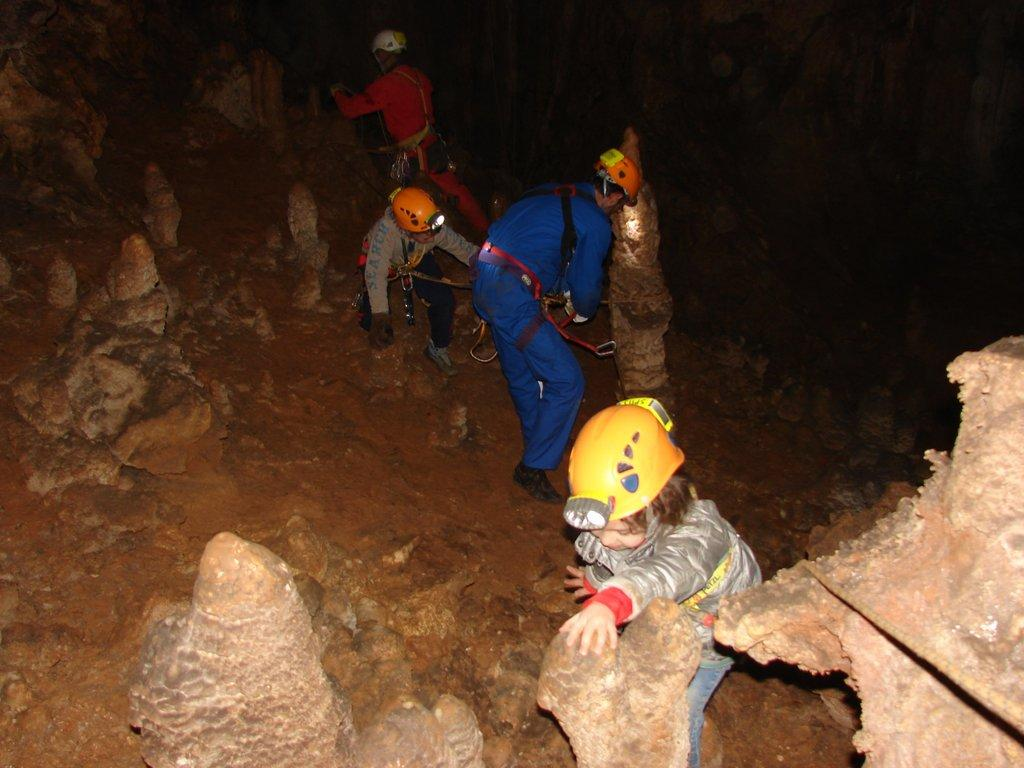How many people are in the image? There are four people in the image. What are the people wearing on their heads? The people are wearing helmets. What is unique about the helmets they are wearing? The helmets have lights attached to them. What can be seen in the background of the image? There are many rocks visible in the image. How can we differentiate the people in the image? The people are wearing different color dresses. What type of secretary can be seen working in the image? There is no secretary present in the image. How do the people in the image stretch their arms? The image does not show the people stretching their arms. 